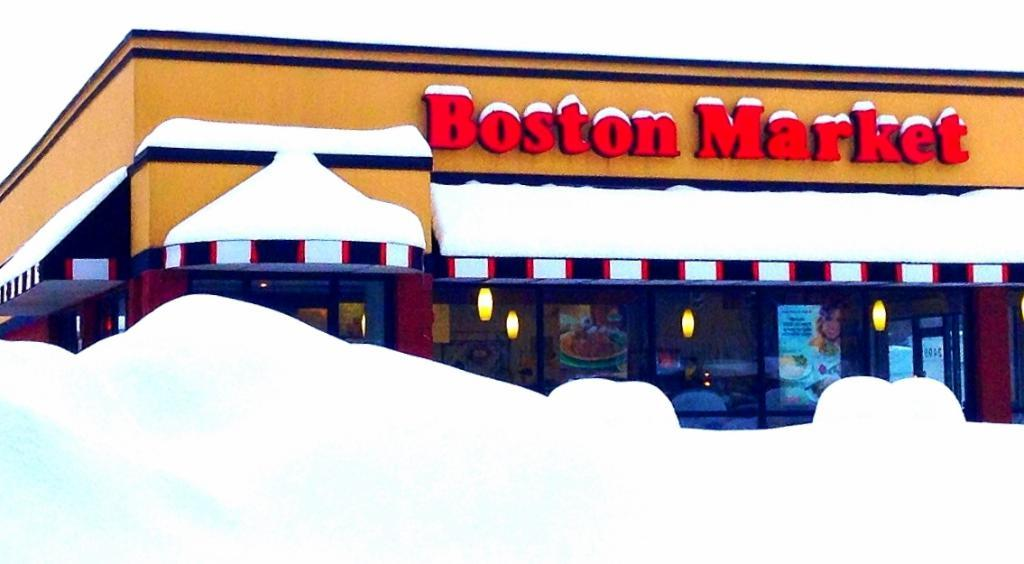What type of establishment is shown in the image? There is a store in the image. What can be seen in the middle of the image? There is some text in the middle of the image. What objects are located at the bottom of the image? There are glasses at the bottom of the image. What is displayed on the glasses? There are posters pasted on the glasses. What can be seen illuminating the store? There are lights visible in the image. What type of marble is used for the floor in the image? There is no information about the floor material in the image, so we cannot determine if marble is used. 